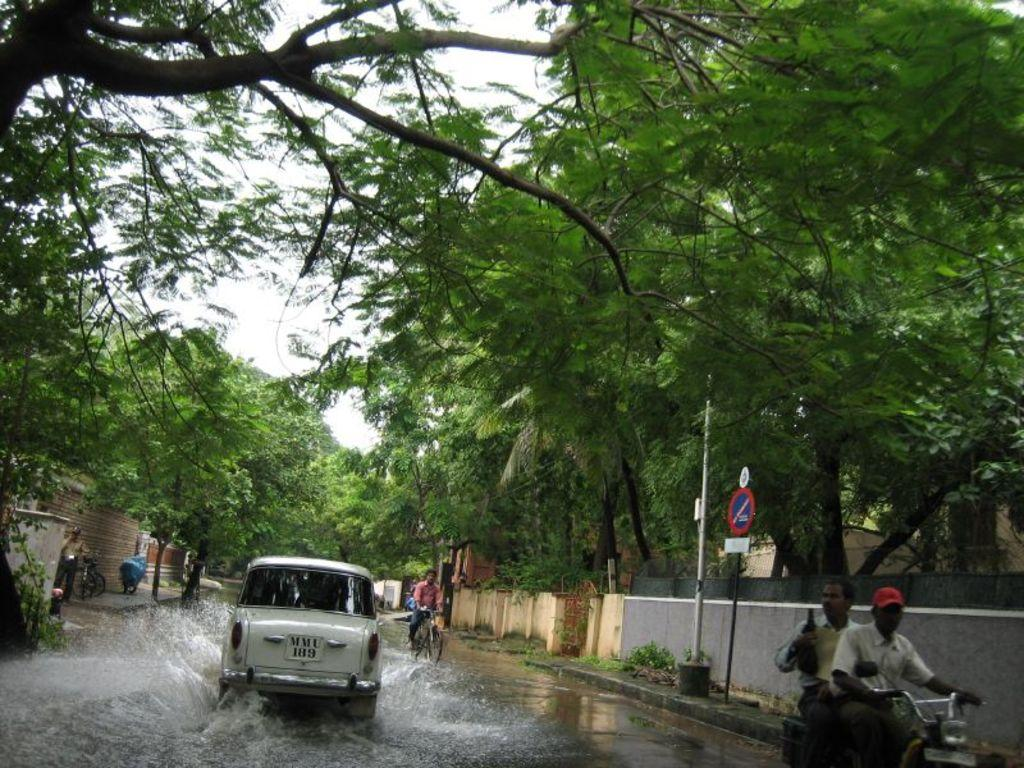What is present on the road at the bottom of the image? There is water on the road at the bottom of the image. What type of vehicle can be seen in the image? There is a car in the image. Are there any other vehicles in the image besides the car? Yes, there are other vehicles in the image. What can be seen on both sides of the road in the image? There are walls and trees on both sides of the road. How does the bee navigate through the battle in the image? There is no bee or battle present in the image; it features a road with water, a car, other vehicles, walls, and trees. 